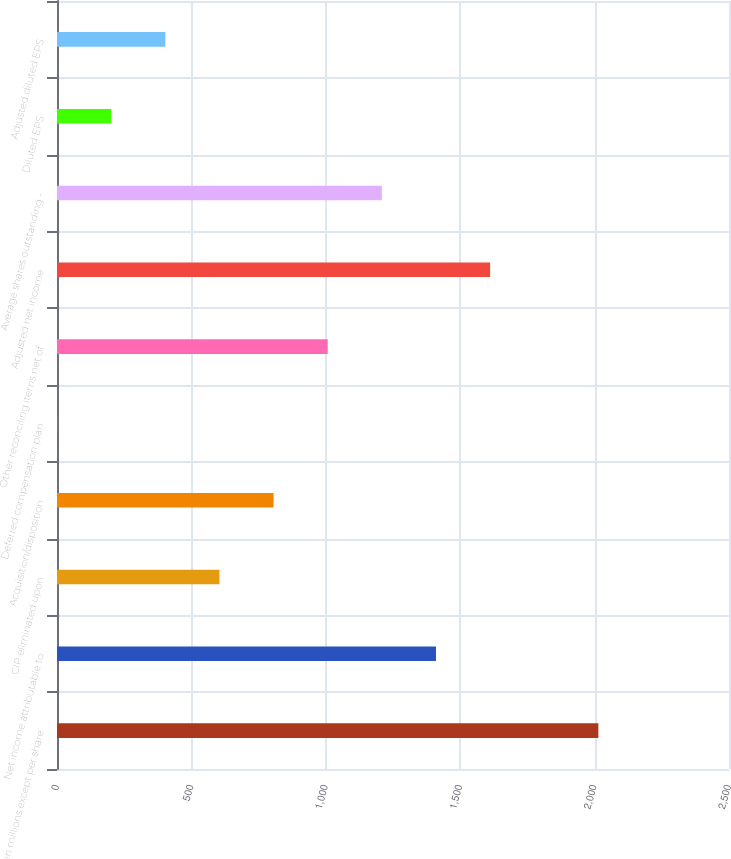<chart> <loc_0><loc_0><loc_500><loc_500><bar_chart><fcel>in millions except per share<fcel>Net income attributable to<fcel>CIP eliminated upon<fcel>Acquisition/disposition<fcel>Deferred compensation plan<fcel>Other reconciling items net of<fcel>Adjusted net income<fcel>Average shares outstanding -<fcel>Diluted EPS<fcel>Adjusted diluted EPS<nl><fcel>2014<fcel>1409.89<fcel>604.41<fcel>805.78<fcel>0.3<fcel>1007.15<fcel>1611.26<fcel>1208.52<fcel>201.67<fcel>403.04<nl></chart> 